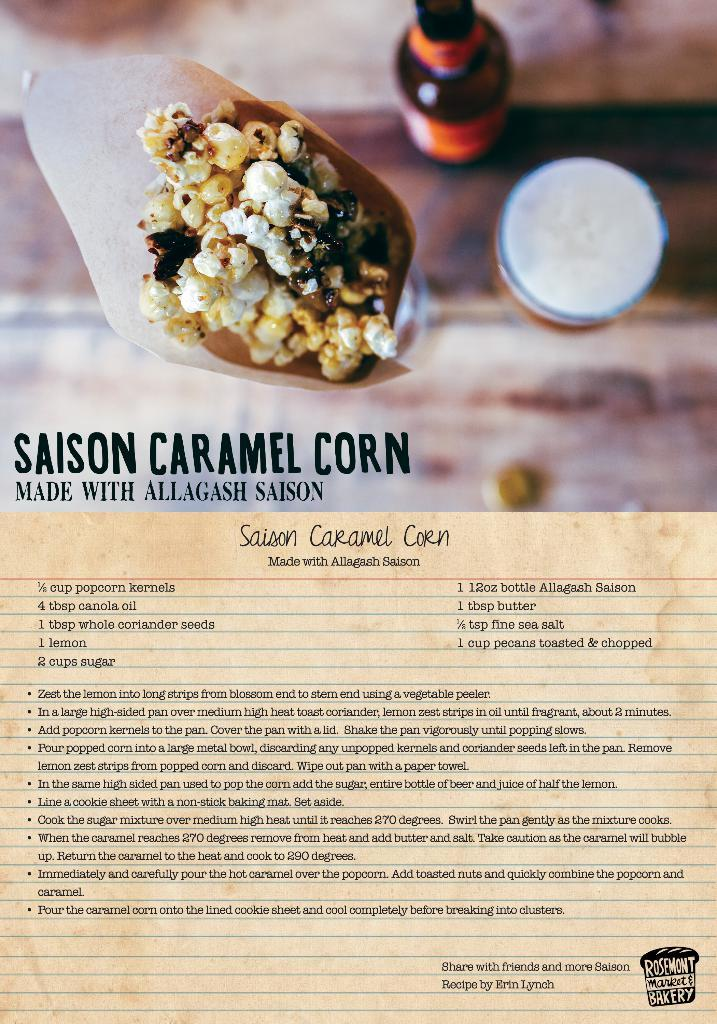<image>
Describe the image concisely. A recipe page with the title Saison Caramel Corn on it. 